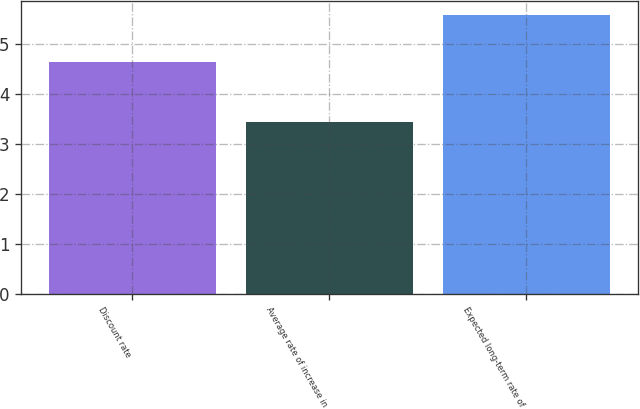Convert chart to OTSL. <chart><loc_0><loc_0><loc_500><loc_500><bar_chart><fcel>Discount rate<fcel>Average rate of increase in<fcel>Expected long-term rate of<nl><fcel>4.65<fcel>3.44<fcel>5.6<nl></chart> 